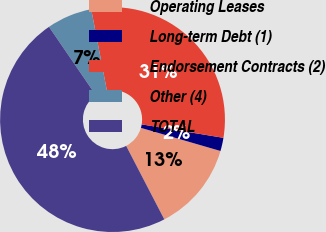Convert chart to OTSL. <chart><loc_0><loc_0><loc_500><loc_500><pie_chart><fcel>Operating Leases<fcel>Long-term Debt (1)<fcel>Endorsement Contracts (2)<fcel>Other (4)<fcel>TOTAL<nl><fcel>12.88%<fcel>1.91%<fcel>30.63%<fcel>6.52%<fcel>48.06%<nl></chart> 